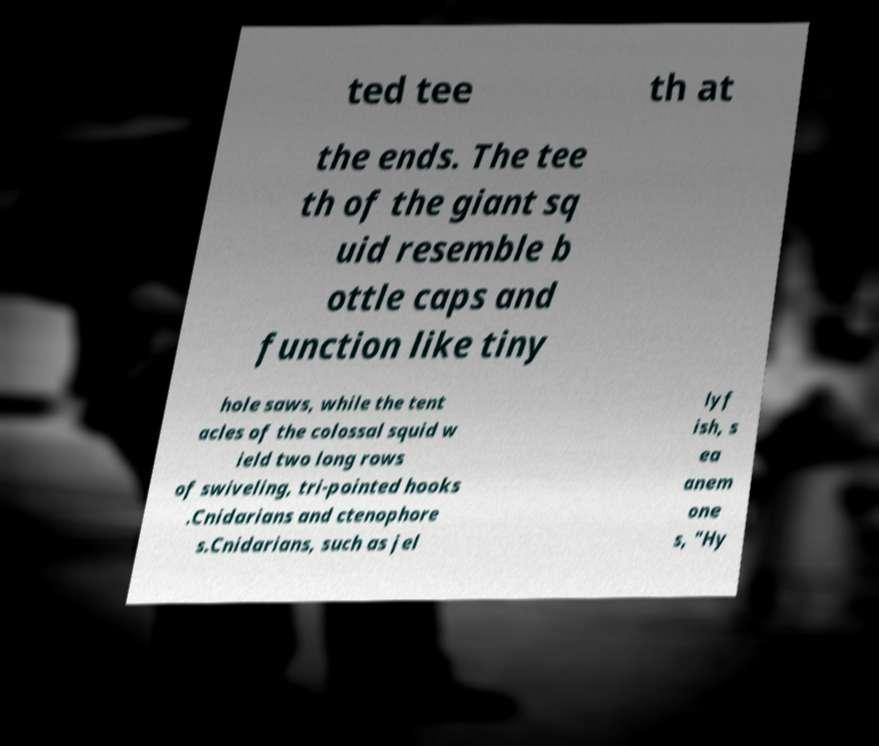Could you extract and type out the text from this image? ted tee th at the ends. The tee th of the giant sq uid resemble b ottle caps and function like tiny hole saws, while the tent acles of the colossal squid w ield two long rows of swiveling, tri-pointed hooks .Cnidarians and ctenophore s.Cnidarians, such as jel lyf ish, s ea anem one s, "Hy 